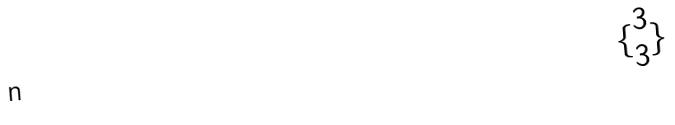<formula> <loc_0><loc_0><loc_500><loc_500>\{ \begin{matrix} 3 \\ 3 \end{matrix} \}</formula> 